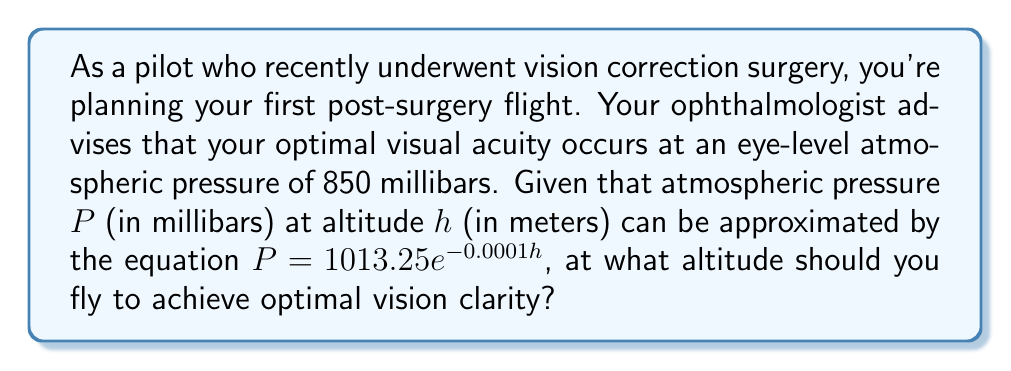Teach me how to tackle this problem. To solve this optimization problem, we need to find the altitude $h$ that corresponds to the optimal atmospheric pressure of 850 millibars. Let's approach this step-by-step:

1) We're given the equation for atmospheric pressure:
   $P = 1013.25 e^{-0.0001h}$

2) We want to find $h$ when $P = 850$. So, we can set up the equation:
   $850 = 1013.25 e^{-0.0001h}$

3) To solve for $h$, let's first divide both sides by 1013.25:
   $\frac{850}{1013.25} = e^{-0.0001h}$

4) Now, let's take the natural logarithm of both sides:
   $\ln(\frac{850}{1013.25}) = \ln(e^{-0.0001h})$

5) The right side simplifies due to the properties of logarithms:
   $\ln(\frac{850}{1013.25}) = -0.0001h$

6) Now we can solve for $h$:
   $h = -\frac{\ln(\frac{850}{1013.25})}{0.0001}$

7) Let's calculate this:
   $h = -\frac{\ln(0.8388)}{0.0001} \approx 1755.9$ meters

8) Rounding to the nearest meter:
   $h = 1756$ meters

Therefore, to achieve optimal vision clarity, you should fly at an altitude of 1756 meters.
Answer: 1756 meters 